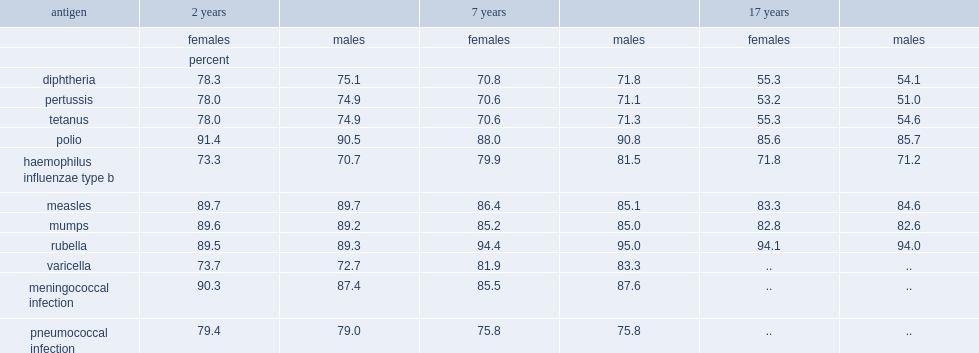What is the percentage of 2-year-old girls were immunized agianst measles? 89.7. What is the percentage of 2-year-old girls were immunized agianst mumps? 89.6. What is the percentage of 2-year-old girls were immunized agianst rubella? 89.5. What is the percentage of 2-year-old girls were immunized agianst meningococcal infection? 90.3. What is the percentage of 2-year-old girls were immunized agianst polio? 91.4. What is the percentage of 2-year-old boys were immunized agianst measles? 89.7. What is the percentage of 2-year-old boys were immunized agianst mumps? 89.2. What is the percentage of 2-year-old boys were immunized agianst rubella? 89.3. What is the percentage of 2-year-old boys were immunized agianst meningococcal infection? 87.4. What is the percentage of 2-year-old boys were immunized agianst polio? 90.5. What is the percentage of 2-year-old girls was immunization coverage? 73.3. What is the percentage of 2-year-old boys was immunization coverage? 70.7. What is the percentage of 2-year-old girls had immunization coverage for diphtheria? 78.3. What is the percentage of 2-year-old girls had immunization coverage for pertussis? 78.0. What is the percentage of 2-year-old girls had immunization coverage for tetaunus? 78.0. What is the percentage of 2-year-old girls had immunization coverage for diphtheria? 75.1. What is the percentage of 2-year-old boys had immunization coverage for pertussis? 74.9. What is the percentage of 2-year-old boys had immunization coverage for tetaunus? 74.9. What is the percentage of 7-year-old girls were up to date on immunization against diphtheria? 70.8. What is the percentage of 7-year-old girls were up to date on immunization against pertussis? 70.6. What is the percentage of 7-year-old girls were up to date on immunization against tetanus? 70.6. What is the percentage of 17-year-old girls were up to date on immunization against diphtheria? 55.3. What is the percentage of 17-year-old girls were up to date on immunization against pertussis? 53.2. What is the percentage of 17-year-old girls were up to date on immunization against tetanus? 55.3. 